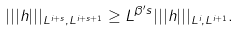<formula> <loc_0><loc_0><loc_500><loc_500>| | | h | | | _ { L ^ { i + s } , L ^ { i + s + 1 } } \geq L ^ { \beta ^ { \prime } s } | | | h | | | _ { L ^ { i } , L ^ { i + 1 } } .</formula> 